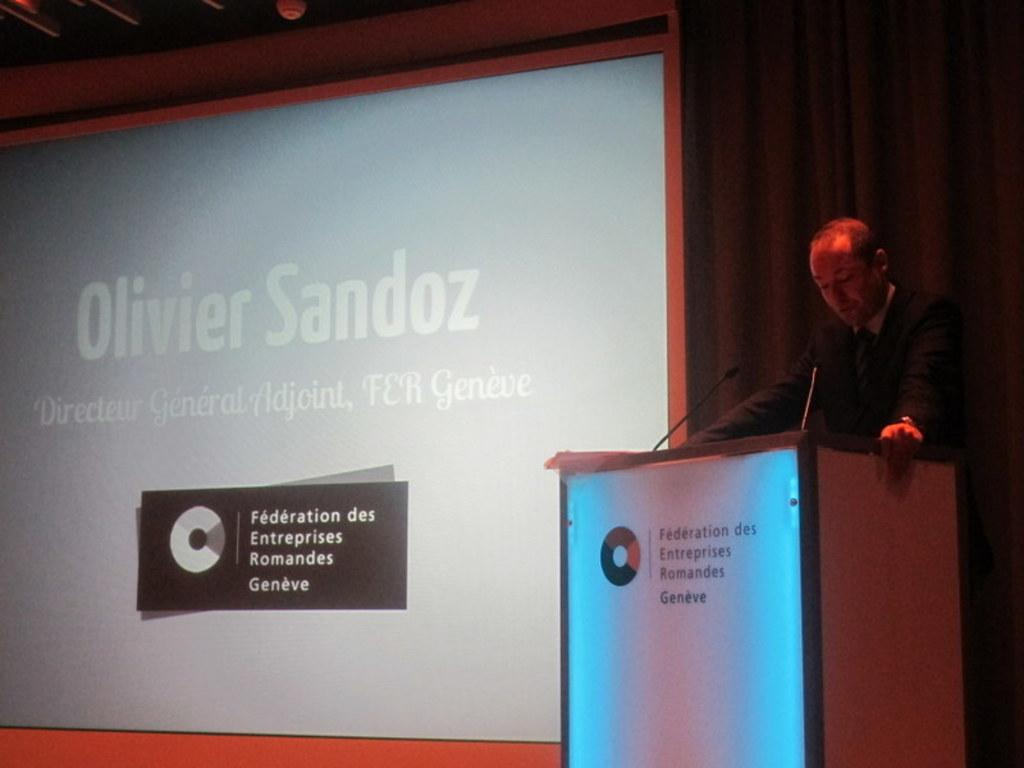What is the man in the image doing? The man is standing in front of a podium. What objects are present on the podium? There are two microphones in the image. What can be seen on the left side of the image? There is a screen on the left side of the image. What type of account is the man discussing in the image? There is no indication in the image that the man is discussing any type of account. 